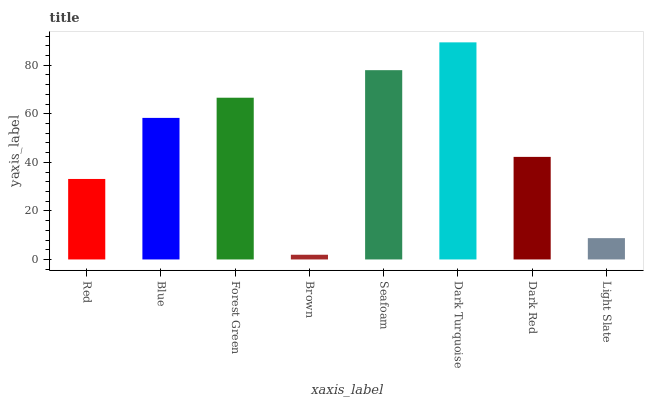Is Brown the minimum?
Answer yes or no. Yes. Is Dark Turquoise the maximum?
Answer yes or no. Yes. Is Blue the minimum?
Answer yes or no. No. Is Blue the maximum?
Answer yes or no. No. Is Blue greater than Red?
Answer yes or no. Yes. Is Red less than Blue?
Answer yes or no. Yes. Is Red greater than Blue?
Answer yes or no. No. Is Blue less than Red?
Answer yes or no. No. Is Blue the high median?
Answer yes or no. Yes. Is Dark Red the low median?
Answer yes or no. Yes. Is Brown the high median?
Answer yes or no. No. Is Red the low median?
Answer yes or no. No. 